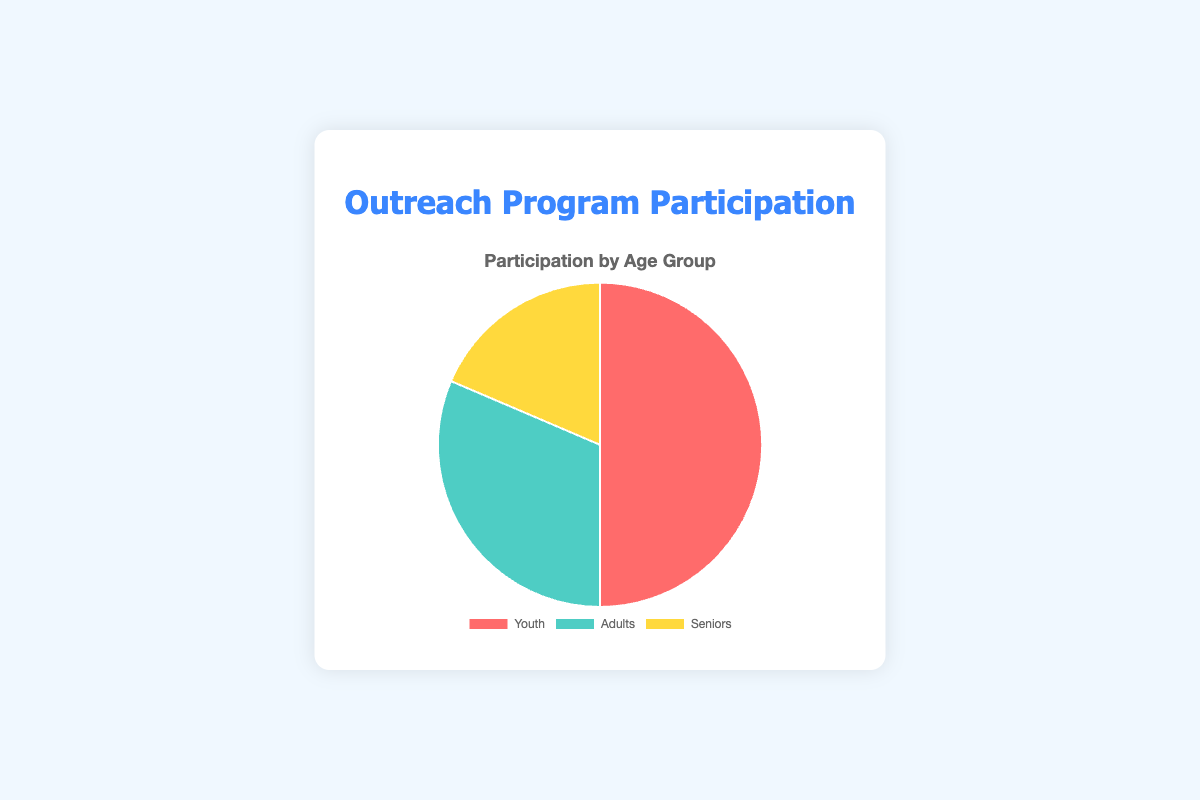Which age group has the highest number of participants? By looking at the pie chart, we can see that the "Youth" segment is the largest compared to "Adults" and "Seniors".
Answer: Youth What is the total number of participants across all age groups? The total is calculated by summing up the participants of each group: Youth (350) + Adults (220) + Seniors (130) = 700.
Answer: 700 How many more participants are there in the Youth group compared to the Seniors group? To find the difference, subtract the number of seniors from the number of youth: 350 (Youth) - 130 (Seniors) = 220.
Answer: 220 What percentage of the total participants are Adults? First, calculate the total number of participants: 350 (Youth) + 220 (Adults) + 130 (Seniors) = 700. Then, find the percentage for Adults: (220 / 700) * 100 ≈ 31.43%.
Answer: 31.43% Which color represents the Adults age group in the pie chart? By examining the color legend of the pie chart, the color associated with "Adults" is green.
Answer: Green What is the combined percentage of Youth and Seniors participants? First, calculate the total number of participants: 350 (Youth) + 220 (Adults) + 130 (Seniors) = 700. Then, sum the participants of Youth and Seniors: 350 (Youth) + 130 (Seniors) = 480. Finally, calculate the percentage: (480 / 700) * 100 ≈ 68.57%.
Answer: 68.57% Is the Adult group larger or smaller than the combined total of Senior participants by more than 100? Calculate the difference: 220 (Adults) - 130 (Seniors) = 90. Since 90 is less than 100, the Adult group is not larger by more than 100.
Answer: Smaller If the participants in the Youth category increased by 50%, how many Youth participants would there be? Current Youth participants are 350. An increase of 50% is calculated as 350 * 0.50 = 175. Adding the increase to the original number: 350 + 175 = 525.
Answer: 525 